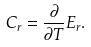Convert formula to latex. <formula><loc_0><loc_0><loc_500><loc_500>C _ { r } = \frac { \partial } { \partial T } E _ { r } .</formula> 